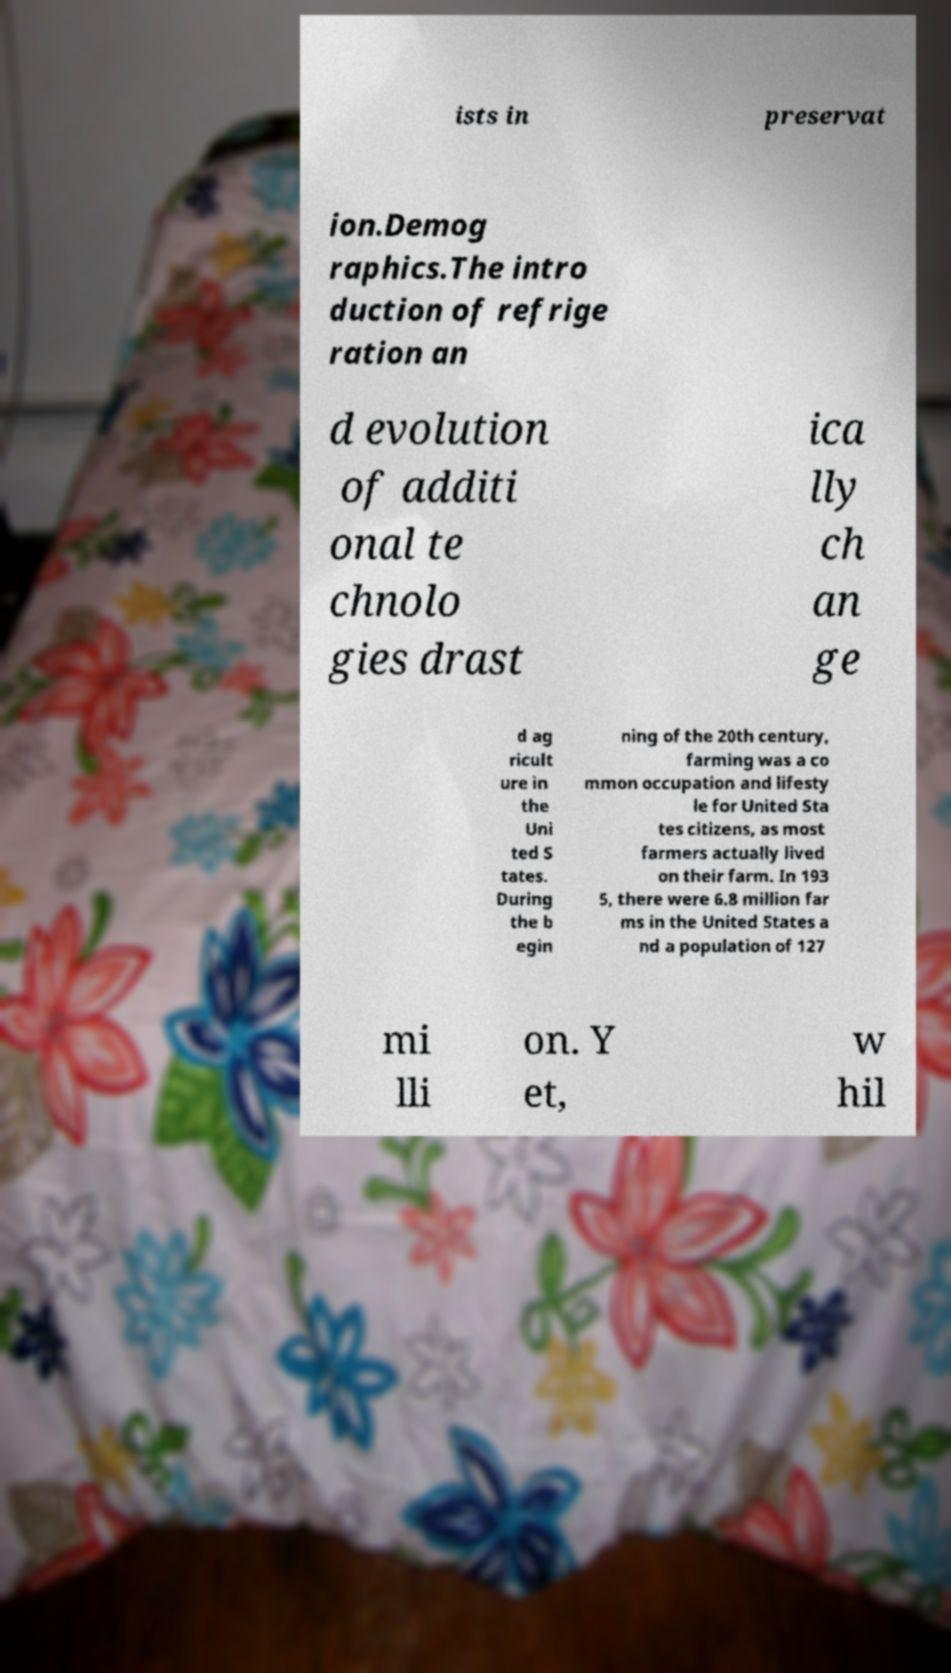What messages or text are displayed in this image? I need them in a readable, typed format. ists in preservat ion.Demog raphics.The intro duction of refrige ration an d evolution of additi onal te chnolo gies drast ica lly ch an ge d ag ricult ure in the Uni ted S tates. During the b egin ning of the 20th century, farming was a co mmon occupation and lifesty le for United Sta tes citizens, as most farmers actually lived on their farm. In 193 5, there were 6.8 million far ms in the United States a nd a population of 127 mi lli on. Y et, w hil 